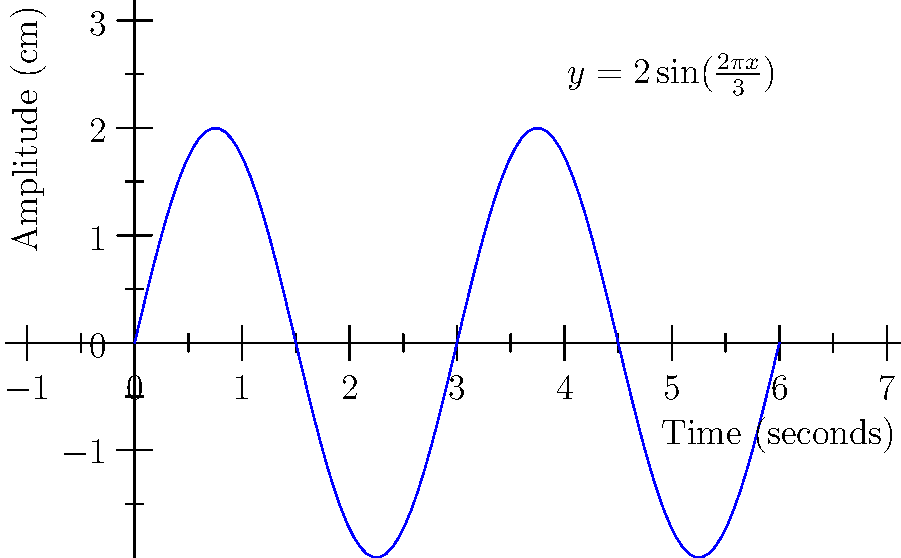As you prepare for the saxophonist's masterclass on sound waves, you come across a diagram representing a sine curve of a sound wave. The curve is described by the equation $y = 2\sin(\frac{2\pi x}{3})$, where $y$ is the amplitude in centimeters and $x$ is the time in seconds. What is the frequency of this sound wave in Hertz (Hz)? To find the frequency of the sound wave, we need to follow these steps:

1) The general form of a sine wave equation is:
   $y = A\sin(2\pi f x + \phi)$
   where $A$ is the amplitude, $f$ is the frequency, and $\phi$ is the phase shift.

2) Comparing our equation $y = 2\sin(\frac{2\pi x}{3})$ to the general form, we can see that:
   $A = 2$ (amplitude)
   $2\pi f = \frac{2\pi}{3}$ (angular frequency)

3) To find $f$, we solve the equation:
   $2\pi f = \frac{2\pi}{3}$

4) Dividing both sides by $2\pi$:
   $f = \frac{1}{3}$

5) The frequency $f$ is measured in Hz (cycles per second), so our final answer is $\frac{1}{3}$ Hz.
Answer: $\frac{1}{3}$ Hz 